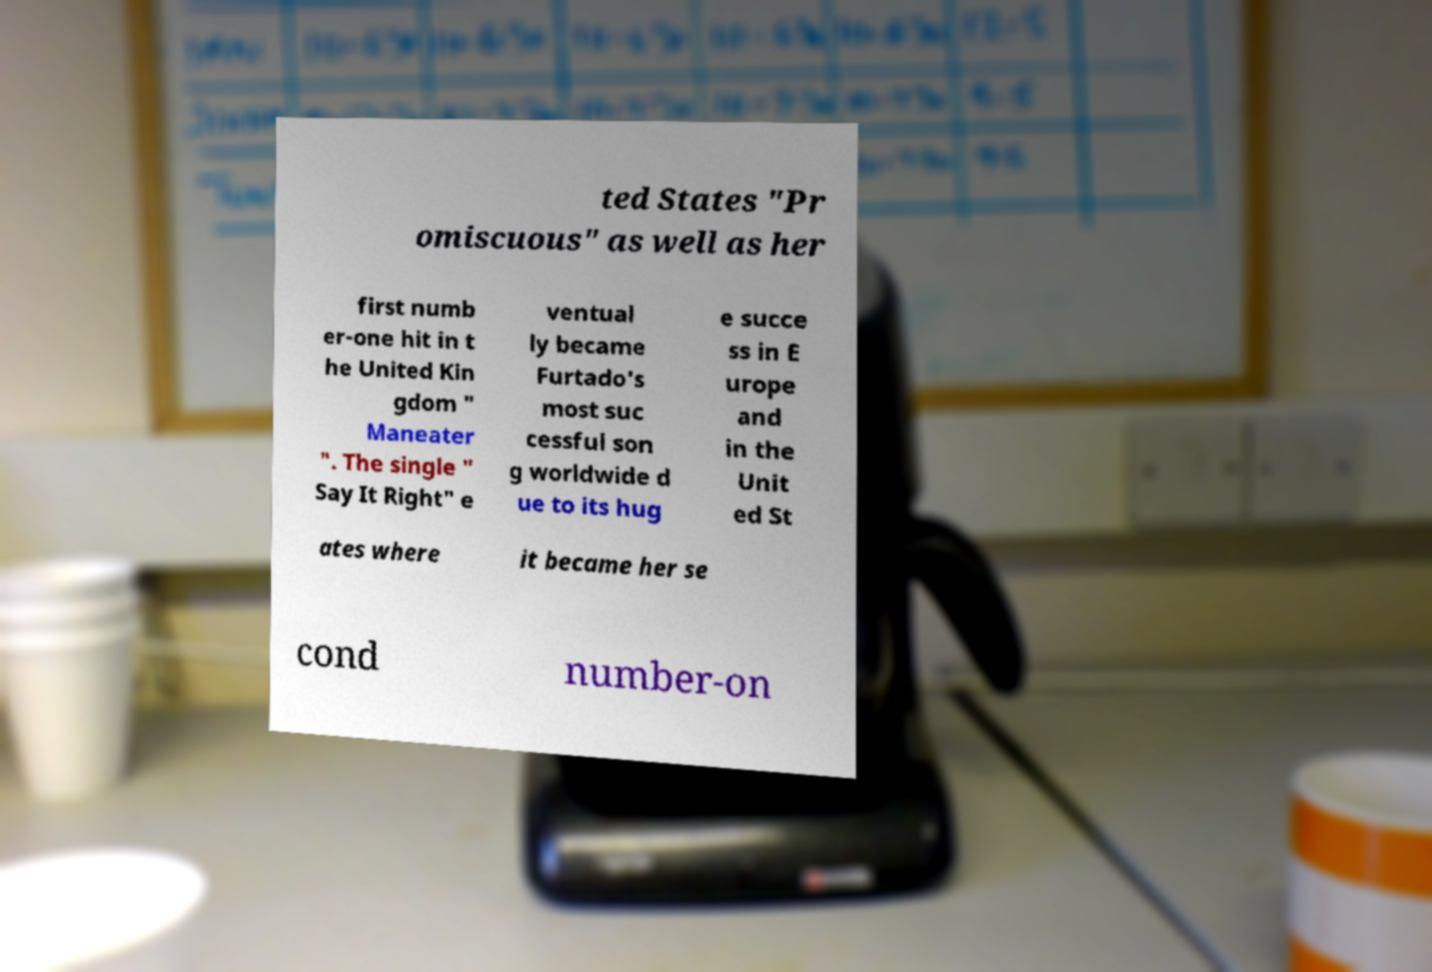There's text embedded in this image that I need extracted. Can you transcribe it verbatim? ted States "Pr omiscuous" as well as her first numb er-one hit in t he United Kin gdom " Maneater ". The single " Say It Right" e ventual ly became Furtado's most suc cessful son g worldwide d ue to its hug e succe ss in E urope and in the Unit ed St ates where it became her se cond number-on 